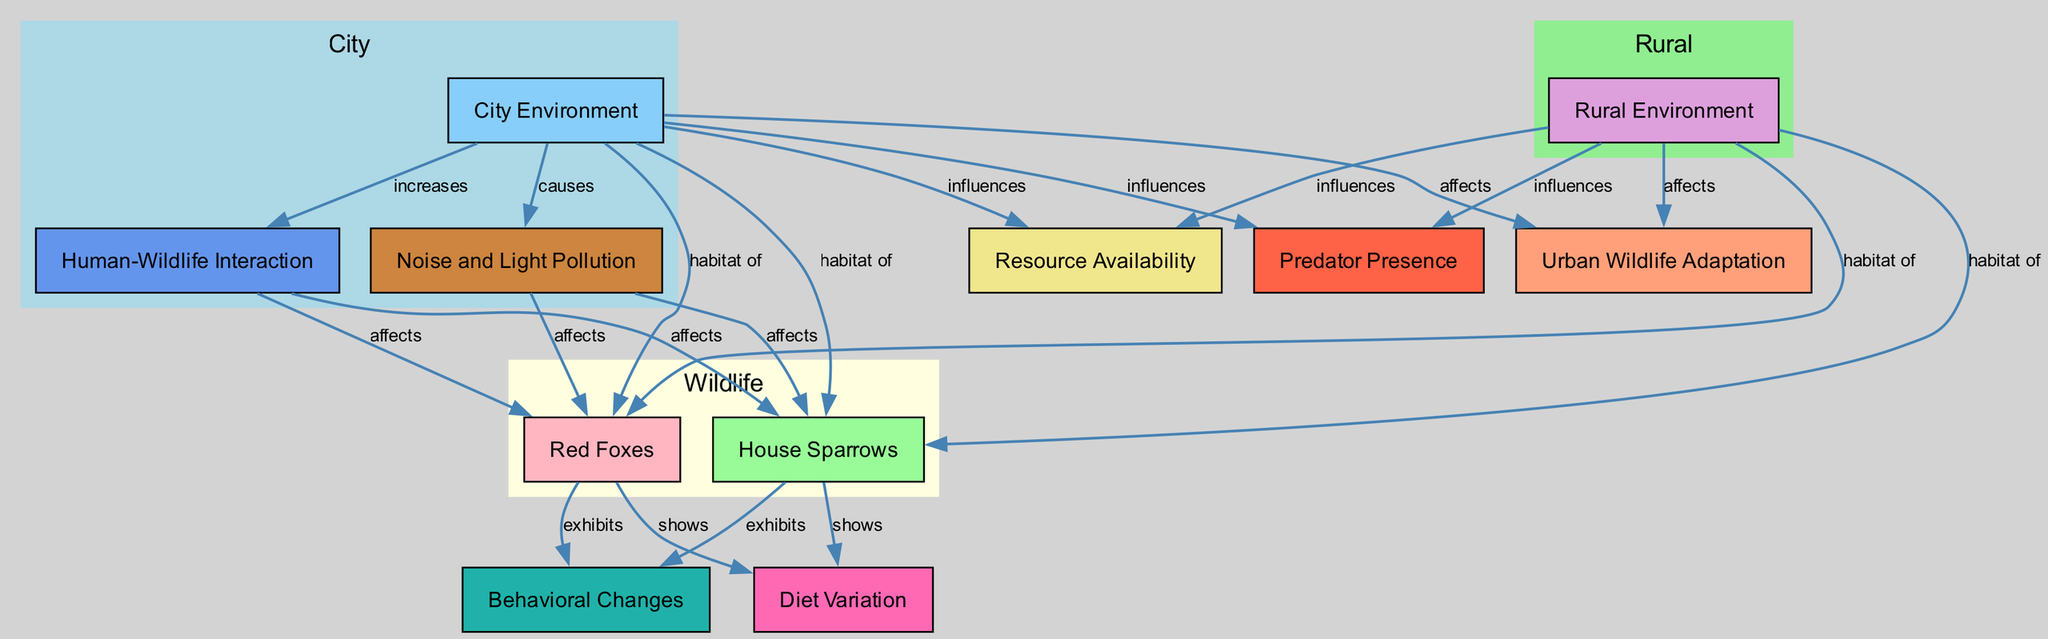What is the central theme of the diagram? The central theme is the adaptation of urban wildlife, shown by various nodes connected to urban and rural environments.
Answer: Urban wildlife adaptation How many species are highlighted in the diagram? There are two species highlighted: House Sparrows and Red Foxes.
Answer: Two Which environment is indicated to influence resource availability? The City Environment influences resource availability as indicated by the connection in the diagram.
Answer: City Environment What is a consequence of noise and light pollution on urban wildlife? Noise and light pollution increases human-wildlife interaction, as indicated by the edges leading from the pollution node.
Answer: Increases human-wildlife interaction What behavioral change do both House Sparrows and Red Foxes exhibit? Both species exhibit behavioral changes which are connected by edges in the diagram.
Answer: Behavioral changes In which environment is resource availability potentially impacted more, urban or rural? The diagram shows that both environments influence resource availability; however, it suggests that the City Environment may have more unique influences.
Answer: City Environment How does human-wildlife interaction differ in urban versus rural settings? The diagram indicates that human-wildlife interaction is affected by both environments but is expected to increase more in urban settings due to higher human density.
Answer: Increased in urban settings Which factor affects the diet variation of House Sparrows? The diet variation of House Sparrows is shown to be affected by the City Environment as per the relationships depicted in the diagram.
Answer: City Environment What type of pollution is addressed in the diagram? The diagram addresses noise and light pollution, specifically impacting urban wildlife.
Answer: Noise and light pollution 